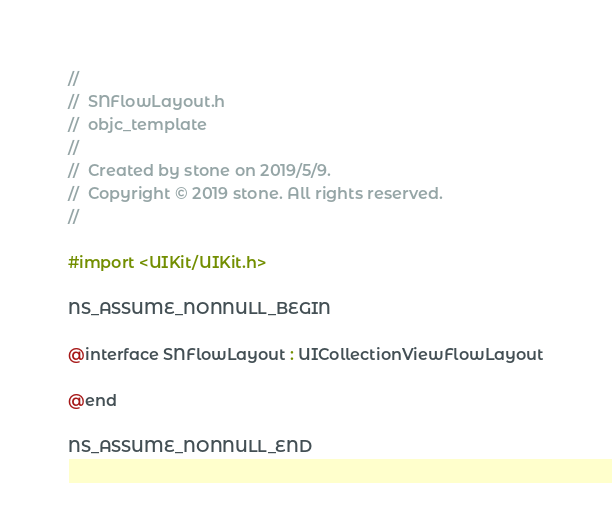Convert code to text. <code><loc_0><loc_0><loc_500><loc_500><_C_>//
//  SNFlowLayout.h
//  objc_template
//
//  Created by stone on 2019/5/9.
//  Copyright © 2019 stone. All rights reserved.
//

#import <UIKit/UIKit.h>

NS_ASSUME_NONNULL_BEGIN

@interface SNFlowLayout : UICollectionViewFlowLayout

@end

NS_ASSUME_NONNULL_END
</code> 